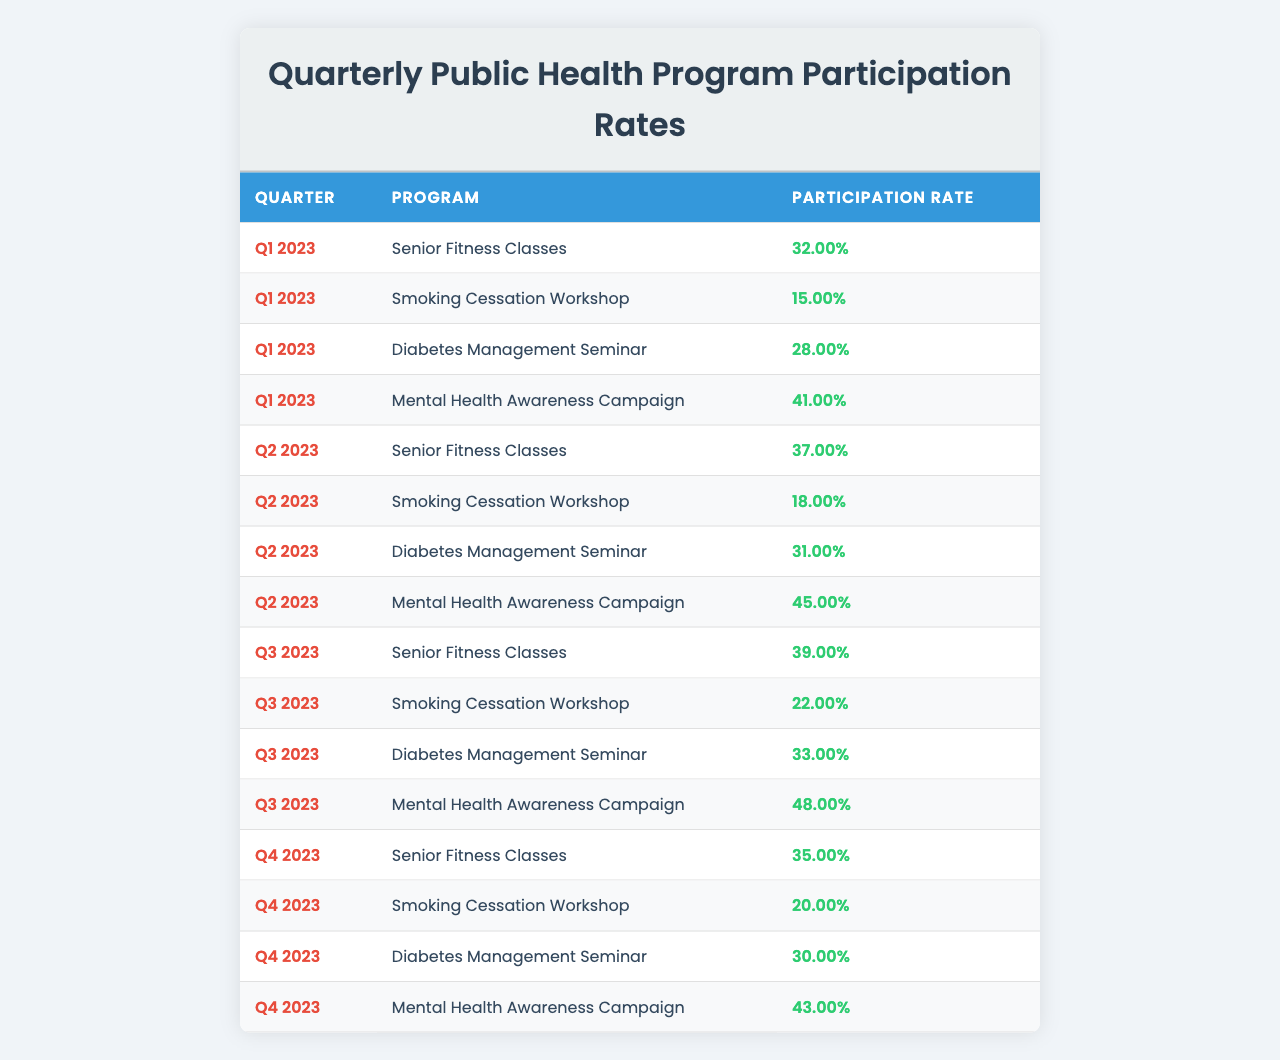What was the participation rate for the Mental Health Awareness Campaign in Q2 2023? In Q2 2023, the Mental Health Awareness Campaign had a participation rate of 0.45. This value can be directly retrieved from the table.
Answer: 0.45 Which program had the highest participation rate in Q3 2023? In Q3 2023, the program with the highest participation rate was the Mental Health Awareness Campaign, with a rate of 0.48. This is found by comparing all program rates for that quarter in the table.
Answer: Mental Health Awareness Campaign What is the overall participation rate for the Senior Fitness Classes across all quarters? The participation rates for Senior Fitness Classes across the quarters are 0.32, 0.37, 0.39, and 0.35. Adding these together gives 0.32 + 0.37 + 0.39 + 0.35 = 1.43. Dividing by 4 (the number of quarters), we get an average of 1.43 / 4 = 0.3575.
Answer: 0.36 Did the participation rate for the Smoking Cessation Workshop increase from Q1 2023 to Q4 2023? The participation rates for the Smoking Cessation Workshop are 0.15 in Q1 2023 and 0.20 in Q4 2023. Since 0.20 is greater than 0.15, it indicates an increase in participation.
Answer: Yes What is the difference in participation rates for the Diabetes Management Seminar between Q1 2023 and Q3 2023? The participation rate for the Diabetes Management Seminar in Q1 2023 is 0.28, and in Q3 2023 it is 0.33. The difference is calculated as 0.33 - 0.28 = 0.05.
Answer: 0.05 Which quarters had a participation rate of over 0.40 for the Mental Health Awareness Campaign? Evaluating each quarter, Q1 has 0.41, Q2 has 0.45, Q3 has 0.48, and Q4 has 0.43. All these quarters indicate rates over 0.40.
Answer: Q1, Q2, Q3, Q4 What was the average participation rate for the Smoking Cessation Workshop over all quarters? The participation rates for the Smoking Cessation Workshop are 0.15, 0.18, 0.22, and 0.20. Summing these gives 0.15 + 0.18 + 0.22 + 0.20 = 0.75. To find the average, divide by 4: 0.75 / 4 = 0.1875.
Answer: 0.19 Which program had the most stable participation rate throughout the quarters? To determine this, we look at the changes in participation rates for all programs across each quarter. The smallest fluctuations indicate stability. The Mental Health Awareness Campaign rates are 0.41, 0.45, 0.48, and 0.43; which range only from 0.41 to 0.48, suggesting relative stability.
Answer: Mental Health Awareness Campaign Was the participation rate for Diabetes Management Seminar higher in Q3 2023 compared to Q2 2023? In Q3 2023, the participation rate for Diabetes Management Seminar was 0.33, whereas in Q2 2023 it was 0.31. Since 0.33 is greater than 0.31, it confirms the higher rate in Q3.
Answer: Yes What program consistently had the lowest participation rates across all quarters? By reviewing the participation rates for all programs, the Smoking Cessation Workshop had the lowest rates in all quarters: 0.15, 0.18, 0.22, and 0.20. This shows it consistently had the lowest participation.
Answer: Smoking Cessation Workshop 